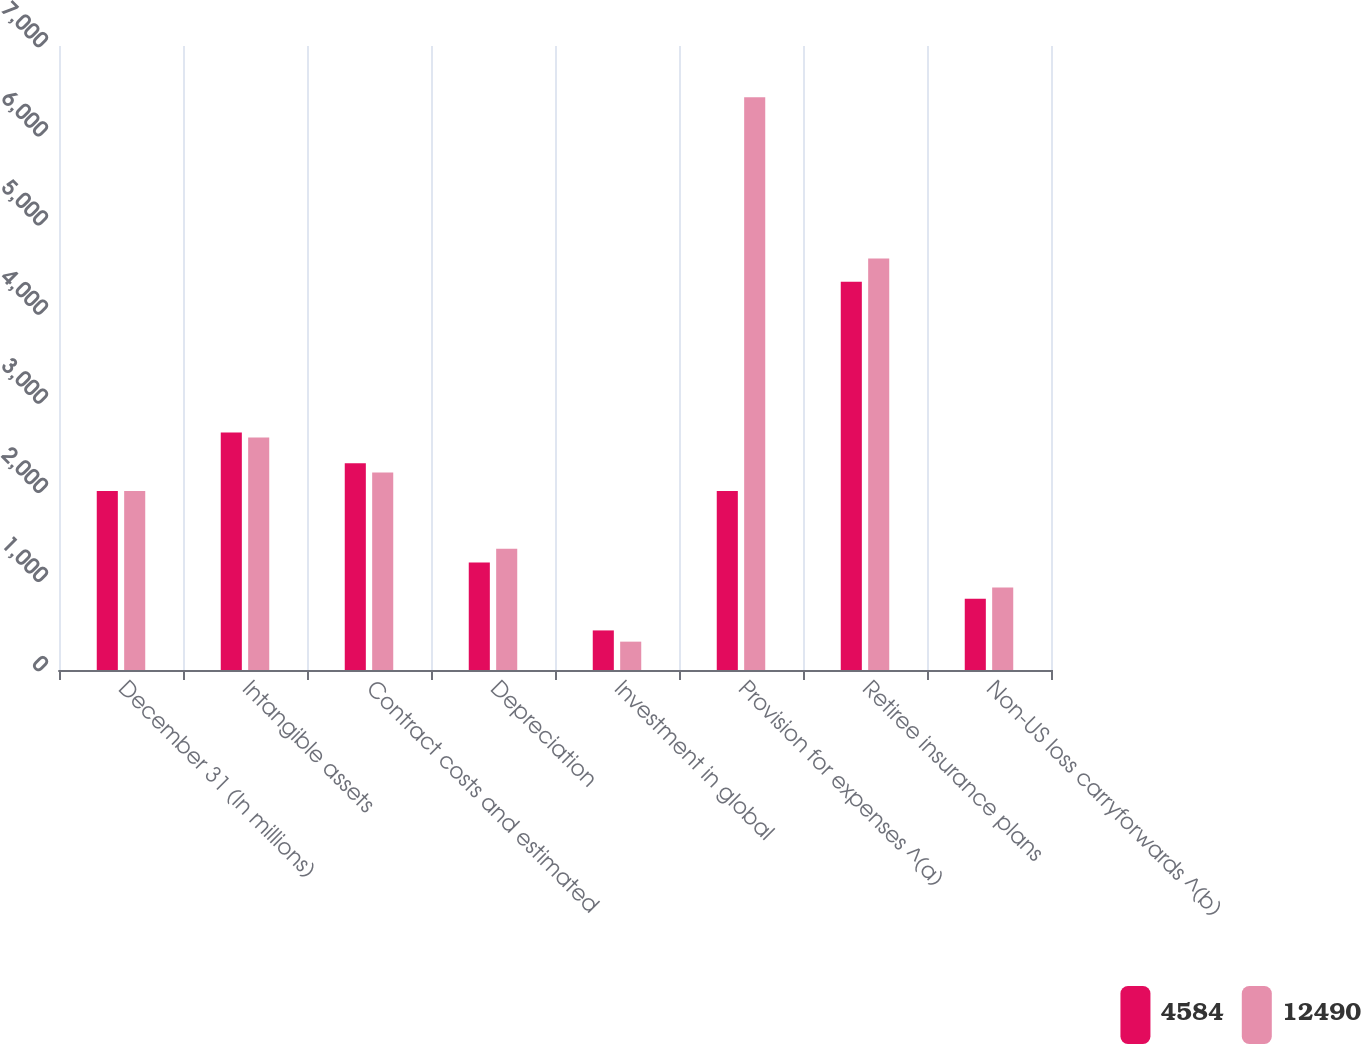<chart> <loc_0><loc_0><loc_500><loc_500><stacked_bar_chart><ecel><fcel>December 31 (In millions)<fcel>Intangible assets<fcel>Contract costs and estimated<fcel>Depreciation<fcel>Investment in global<fcel>Provision for expenses ^(a)<fcel>Retiree insurance plans<fcel>Non-US loss carryforwards ^(b)<nl><fcel>4584<fcel>2008<fcel>2664<fcel>2319<fcel>1205<fcel>444<fcel>2008<fcel>4355<fcel>800<nl><fcel>12490<fcel>2007<fcel>2609<fcel>2215<fcel>1360<fcel>318<fcel>6426<fcel>4616<fcel>925<nl></chart> 